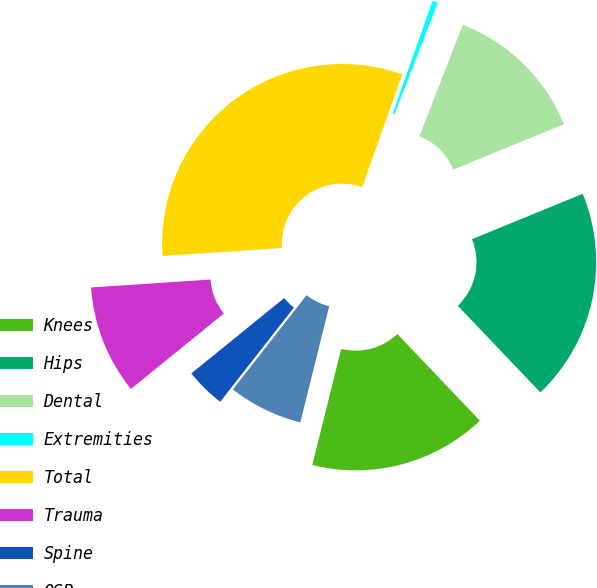Convert chart. <chart><loc_0><loc_0><loc_500><loc_500><pie_chart><fcel>Knees<fcel>Hips<fcel>Dental<fcel>Extremities<fcel>Total<fcel>Trauma<fcel>Spine<fcel>OSP<nl><fcel>15.99%<fcel>19.08%<fcel>12.89%<fcel>0.5%<fcel>31.47%<fcel>9.79%<fcel>3.59%<fcel>6.69%<nl></chart> 